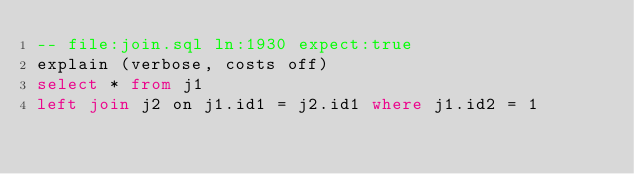<code> <loc_0><loc_0><loc_500><loc_500><_SQL_>-- file:join.sql ln:1930 expect:true
explain (verbose, costs off)
select * from j1
left join j2 on j1.id1 = j2.id1 where j1.id2 = 1
</code> 